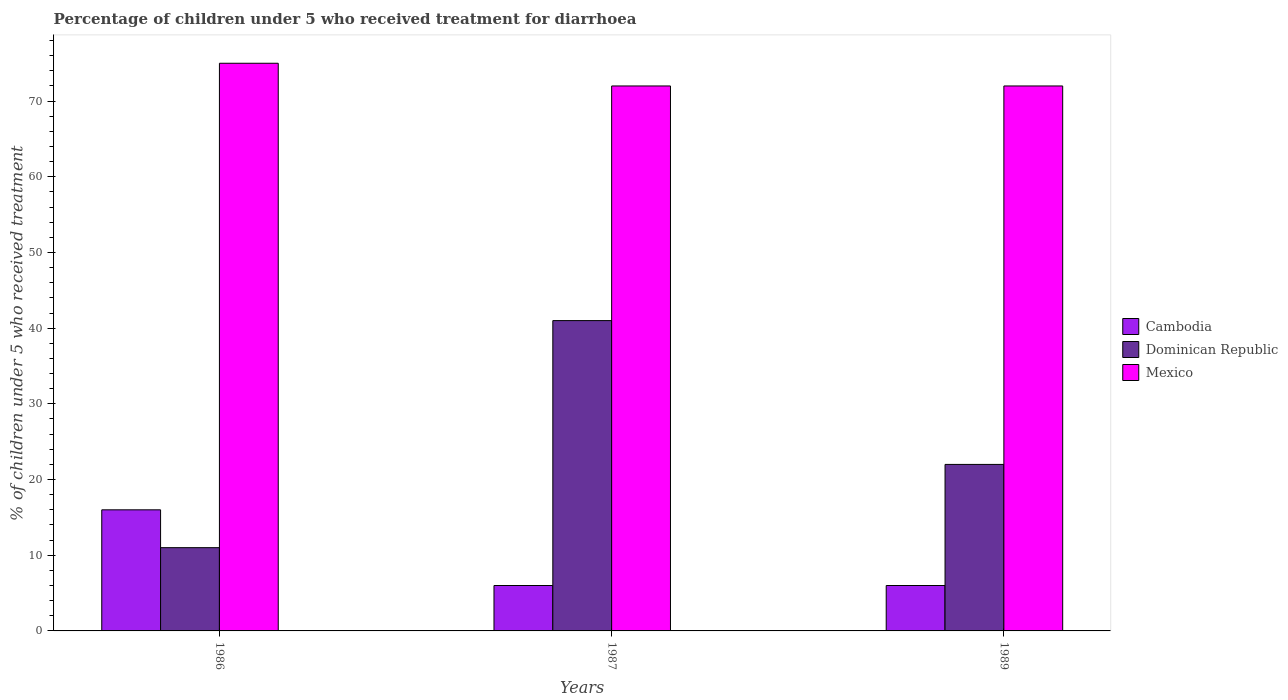How many different coloured bars are there?
Offer a very short reply. 3. How many groups of bars are there?
Provide a short and direct response. 3. Are the number of bars per tick equal to the number of legend labels?
Ensure brevity in your answer.  Yes. How many bars are there on the 3rd tick from the right?
Your response must be concise. 3. What is the label of the 3rd group of bars from the left?
Keep it short and to the point. 1989. In how many cases, is the number of bars for a given year not equal to the number of legend labels?
Ensure brevity in your answer.  0. Across all years, what is the maximum percentage of children who received treatment for diarrhoea  in Dominican Republic?
Your response must be concise. 41. In which year was the percentage of children who received treatment for diarrhoea  in Mexico maximum?
Provide a succinct answer. 1986. In which year was the percentage of children who received treatment for diarrhoea  in Dominican Republic minimum?
Ensure brevity in your answer.  1986. What is the total percentage of children who received treatment for diarrhoea  in Cambodia in the graph?
Provide a succinct answer. 28. What is the average percentage of children who received treatment for diarrhoea  in Dominican Republic per year?
Keep it short and to the point. 24.67. In the year 1986, what is the difference between the percentage of children who received treatment for diarrhoea  in Dominican Republic and percentage of children who received treatment for diarrhoea  in Mexico?
Give a very brief answer. -64. What is the ratio of the percentage of children who received treatment for diarrhoea  in Mexico in 1987 to that in 1989?
Offer a terse response. 1. Is the difference between the percentage of children who received treatment for diarrhoea  in Dominican Republic in 1987 and 1989 greater than the difference between the percentage of children who received treatment for diarrhoea  in Mexico in 1987 and 1989?
Provide a succinct answer. Yes. Is the sum of the percentage of children who received treatment for diarrhoea  in Dominican Republic in 1987 and 1989 greater than the maximum percentage of children who received treatment for diarrhoea  in Cambodia across all years?
Your answer should be compact. Yes. What does the 1st bar from the left in 1989 represents?
Give a very brief answer. Cambodia. What does the 3rd bar from the right in 1989 represents?
Ensure brevity in your answer.  Cambodia. Is it the case that in every year, the sum of the percentage of children who received treatment for diarrhoea  in Dominican Republic and percentage of children who received treatment for diarrhoea  in Mexico is greater than the percentage of children who received treatment for diarrhoea  in Cambodia?
Provide a short and direct response. Yes. Are all the bars in the graph horizontal?
Give a very brief answer. No. How many years are there in the graph?
Give a very brief answer. 3. What is the difference between two consecutive major ticks on the Y-axis?
Keep it short and to the point. 10. Are the values on the major ticks of Y-axis written in scientific E-notation?
Your answer should be very brief. No. Where does the legend appear in the graph?
Provide a short and direct response. Center right. How are the legend labels stacked?
Provide a succinct answer. Vertical. What is the title of the graph?
Provide a short and direct response. Percentage of children under 5 who received treatment for diarrhoea. Does "Syrian Arab Republic" appear as one of the legend labels in the graph?
Provide a short and direct response. No. What is the label or title of the Y-axis?
Offer a terse response. % of children under 5 who received treatment. What is the % of children under 5 who received treatment in Dominican Republic in 1986?
Keep it short and to the point. 11. What is the % of children under 5 who received treatment in Mexico in 1986?
Your answer should be compact. 75. What is the % of children under 5 who received treatment in Dominican Republic in 1987?
Provide a succinct answer. 41. What is the % of children under 5 who received treatment of Mexico in 1987?
Keep it short and to the point. 72. What is the % of children under 5 who received treatment in Cambodia in 1989?
Keep it short and to the point. 6. Across all years, what is the maximum % of children under 5 who received treatment in Dominican Republic?
Ensure brevity in your answer.  41. Across all years, what is the maximum % of children under 5 who received treatment of Mexico?
Provide a short and direct response. 75. Across all years, what is the minimum % of children under 5 who received treatment in Cambodia?
Your response must be concise. 6. Across all years, what is the minimum % of children under 5 who received treatment of Dominican Republic?
Offer a very short reply. 11. What is the total % of children under 5 who received treatment in Cambodia in the graph?
Your answer should be compact. 28. What is the total % of children under 5 who received treatment in Mexico in the graph?
Your response must be concise. 219. What is the difference between the % of children under 5 who received treatment of Mexico in 1986 and that in 1987?
Your answer should be compact. 3. What is the difference between the % of children under 5 who received treatment of Cambodia in 1986 and that in 1989?
Offer a terse response. 10. What is the difference between the % of children under 5 who received treatment in Cambodia in 1987 and that in 1989?
Your answer should be compact. 0. What is the difference between the % of children under 5 who received treatment in Mexico in 1987 and that in 1989?
Give a very brief answer. 0. What is the difference between the % of children under 5 who received treatment in Cambodia in 1986 and the % of children under 5 who received treatment in Dominican Republic in 1987?
Your answer should be compact. -25. What is the difference between the % of children under 5 who received treatment of Cambodia in 1986 and the % of children under 5 who received treatment of Mexico in 1987?
Give a very brief answer. -56. What is the difference between the % of children under 5 who received treatment of Dominican Republic in 1986 and the % of children under 5 who received treatment of Mexico in 1987?
Give a very brief answer. -61. What is the difference between the % of children under 5 who received treatment in Cambodia in 1986 and the % of children under 5 who received treatment in Dominican Republic in 1989?
Ensure brevity in your answer.  -6. What is the difference between the % of children under 5 who received treatment of Cambodia in 1986 and the % of children under 5 who received treatment of Mexico in 1989?
Provide a succinct answer. -56. What is the difference between the % of children under 5 who received treatment in Dominican Republic in 1986 and the % of children under 5 who received treatment in Mexico in 1989?
Ensure brevity in your answer.  -61. What is the difference between the % of children under 5 who received treatment of Cambodia in 1987 and the % of children under 5 who received treatment of Mexico in 1989?
Your response must be concise. -66. What is the difference between the % of children under 5 who received treatment in Dominican Republic in 1987 and the % of children under 5 who received treatment in Mexico in 1989?
Provide a succinct answer. -31. What is the average % of children under 5 who received treatment in Cambodia per year?
Your answer should be very brief. 9.33. What is the average % of children under 5 who received treatment of Dominican Republic per year?
Ensure brevity in your answer.  24.67. In the year 1986, what is the difference between the % of children under 5 who received treatment in Cambodia and % of children under 5 who received treatment in Dominican Republic?
Keep it short and to the point. 5. In the year 1986, what is the difference between the % of children under 5 who received treatment in Cambodia and % of children under 5 who received treatment in Mexico?
Provide a succinct answer. -59. In the year 1986, what is the difference between the % of children under 5 who received treatment of Dominican Republic and % of children under 5 who received treatment of Mexico?
Your answer should be compact. -64. In the year 1987, what is the difference between the % of children under 5 who received treatment of Cambodia and % of children under 5 who received treatment of Dominican Republic?
Offer a terse response. -35. In the year 1987, what is the difference between the % of children under 5 who received treatment of Cambodia and % of children under 5 who received treatment of Mexico?
Keep it short and to the point. -66. In the year 1987, what is the difference between the % of children under 5 who received treatment of Dominican Republic and % of children under 5 who received treatment of Mexico?
Ensure brevity in your answer.  -31. In the year 1989, what is the difference between the % of children under 5 who received treatment of Cambodia and % of children under 5 who received treatment of Dominican Republic?
Your response must be concise. -16. In the year 1989, what is the difference between the % of children under 5 who received treatment of Cambodia and % of children under 5 who received treatment of Mexico?
Make the answer very short. -66. What is the ratio of the % of children under 5 who received treatment of Cambodia in 1986 to that in 1987?
Your answer should be compact. 2.67. What is the ratio of the % of children under 5 who received treatment in Dominican Republic in 1986 to that in 1987?
Offer a very short reply. 0.27. What is the ratio of the % of children under 5 who received treatment of Mexico in 1986 to that in 1987?
Your answer should be very brief. 1.04. What is the ratio of the % of children under 5 who received treatment in Cambodia in 1986 to that in 1989?
Your answer should be very brief. 2.67. What is the ratio of the % of children under 5 who received treatment in Mexico in 1986 to that in 1989?
Keep it short and to the point. 1.04. What is the ratio of the % of children under 5 who received treatment in Dominican Republic in 1987 to that in 1989?
Ensure brevity in your answer.  1.86. What is the ratio of the % of children under 5 who received treatment in Mexico in 1987 to that in 1989?
Offer a very short reply. 1. What is the difference between the highest and the second highest % of children under 5 who received treatment of Cambodia?
Keep it short and to the point. 10. What is the difference between the highest and the second highest % of children under 5 who received treatment of Mexico?
Your answer should be very brief. 3. What is the difference between the highest and the lowest % of children under 5 who received treatment in Dominican Republic?
Your answer should be very brief. 30. 